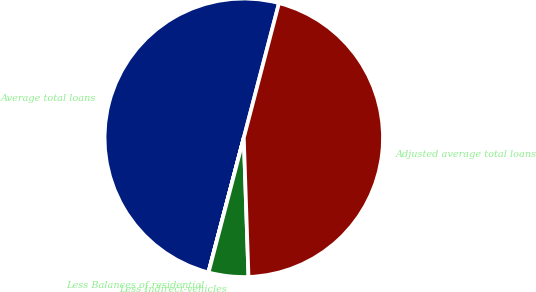<chart> <loc_0><loc_0><loc_500><loc_500><pie_chart><fcel>Average total loans<fcel>Less Balances of residential<fcel>Less Indirect-vehicles<fcel>Adjusted average total loans<nl><fcel>49.98%<fcel>0.02%<fcel>4.61%<fcel>45.39%<nl></chart> 